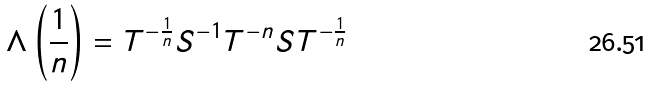Convert formula to latex. <formula><loc_0><loc_0><loc_500><loc_500>\Lambda \left ( \frac { 1 } { n } \right ) = T ^ { - \frac { 1 } { n } } S ^ { - 1 } T ^ { - n } S T ^ { - \frac { 1 } { n } }</formula> 